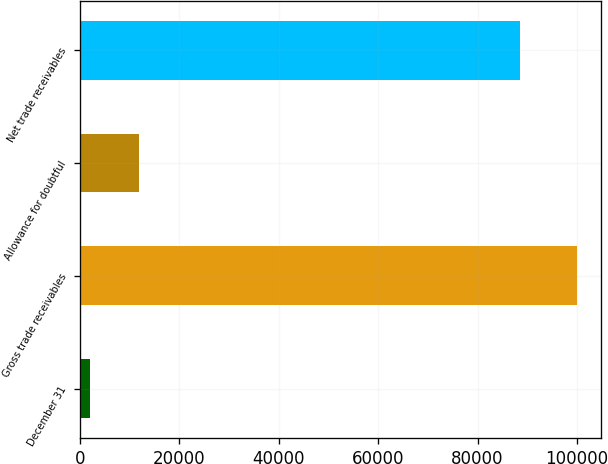Convert chart. <chart><loc_0><loc_0><loc_500><loc_500><bar_chart><fcel>December 31<fcel>Gross trade receivables<fcel>Allowance for doubtful<fcel>Net trade receivables<nl><fcel>2016<fcel>99933<fcel>11807.7<fcel>88490<nl></chart> 